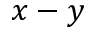<formula> <loc_0><loc_0><loc_500><loc_500>x - y</formula> 